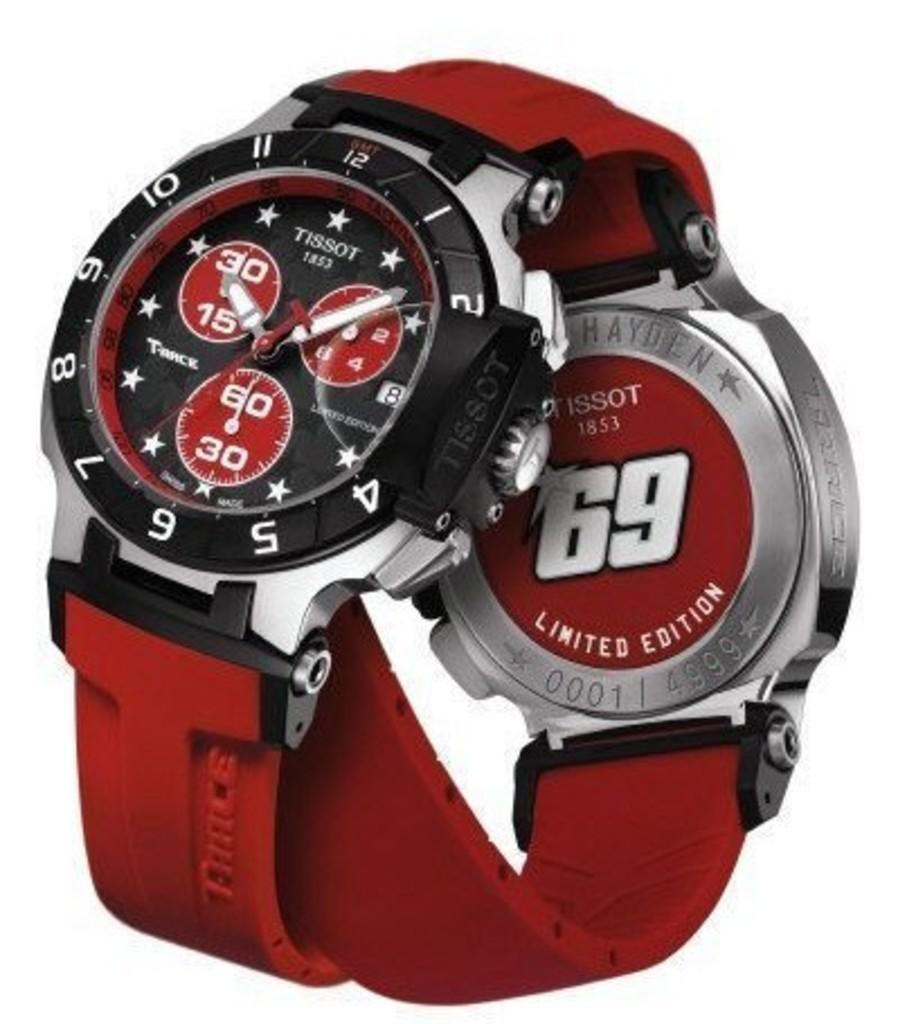<image>
Write a terse but informative summary of the picture. Two red Limited Edition Tissot 69 watchest are displayed so that you can see the front and back. 